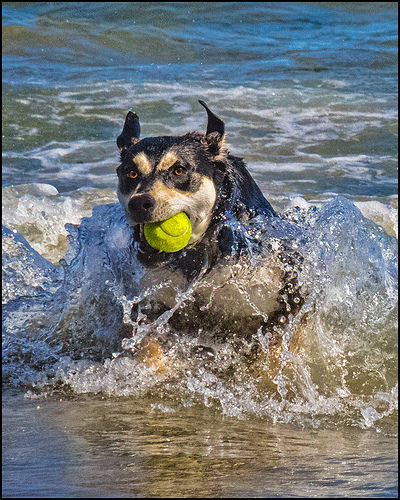<image>
Is the dog to the right of the ball? No. The dog is not to the right of the ball. The horizontal positioning shows a different relationship. 